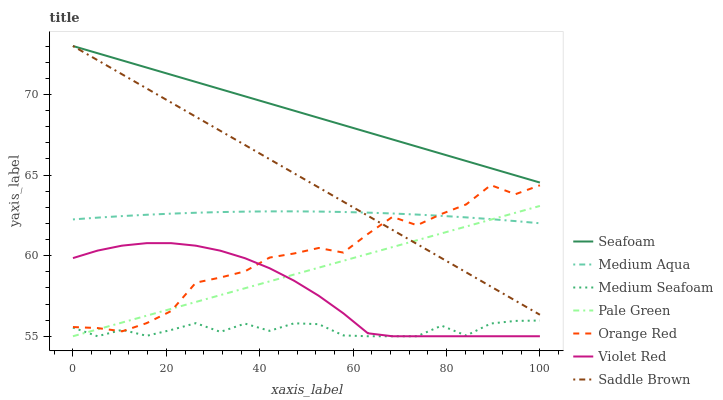Does Medium Seafoam have the minimum area under the curve?
Answer yes or no. Yes. Does Seafoam have the maximum area under the curve?
Answer yes or no. Yes. Does Seafoam have the minimum area under the curve?
Answer yes or no. No. Does Medium Seafoam have the maximum area under the curve?
Answer yes or no. No. Is Pale Green the smoothest?
Answer yes or no. Yes. Is Orange Red the roughest?
Answer yes or no. Yes. Is Seafoam the smoothest?
Answer yes or no. No. Is Seafoam the roughest?
Answer yes or no. No. Does Seafoam have the lowest value?
Answer yes or no. No. Does Saddle Brown have the highest value?
Answer yes or no. Yes. Does Medium Seafoam have the highest value?
Answer yes or no. No. Is Medium Seafoam less than Medium Aqua?
Answer yes or no. Yes. Is Saddle Brown greater than Medium Seafoam?
Answer yes or no. Yes. Does Orange Red intersect Medium Seafoam?
Answer yes or no. Yes. Is Orange Red less than Medium Seafoam?
Answer yes or no. No. Is Orange Red greater than Medium Seafoam?
Answer yes or no. No. Does Medium Seafoam intersect Medium Aqua?
Answer yes or no. No. 